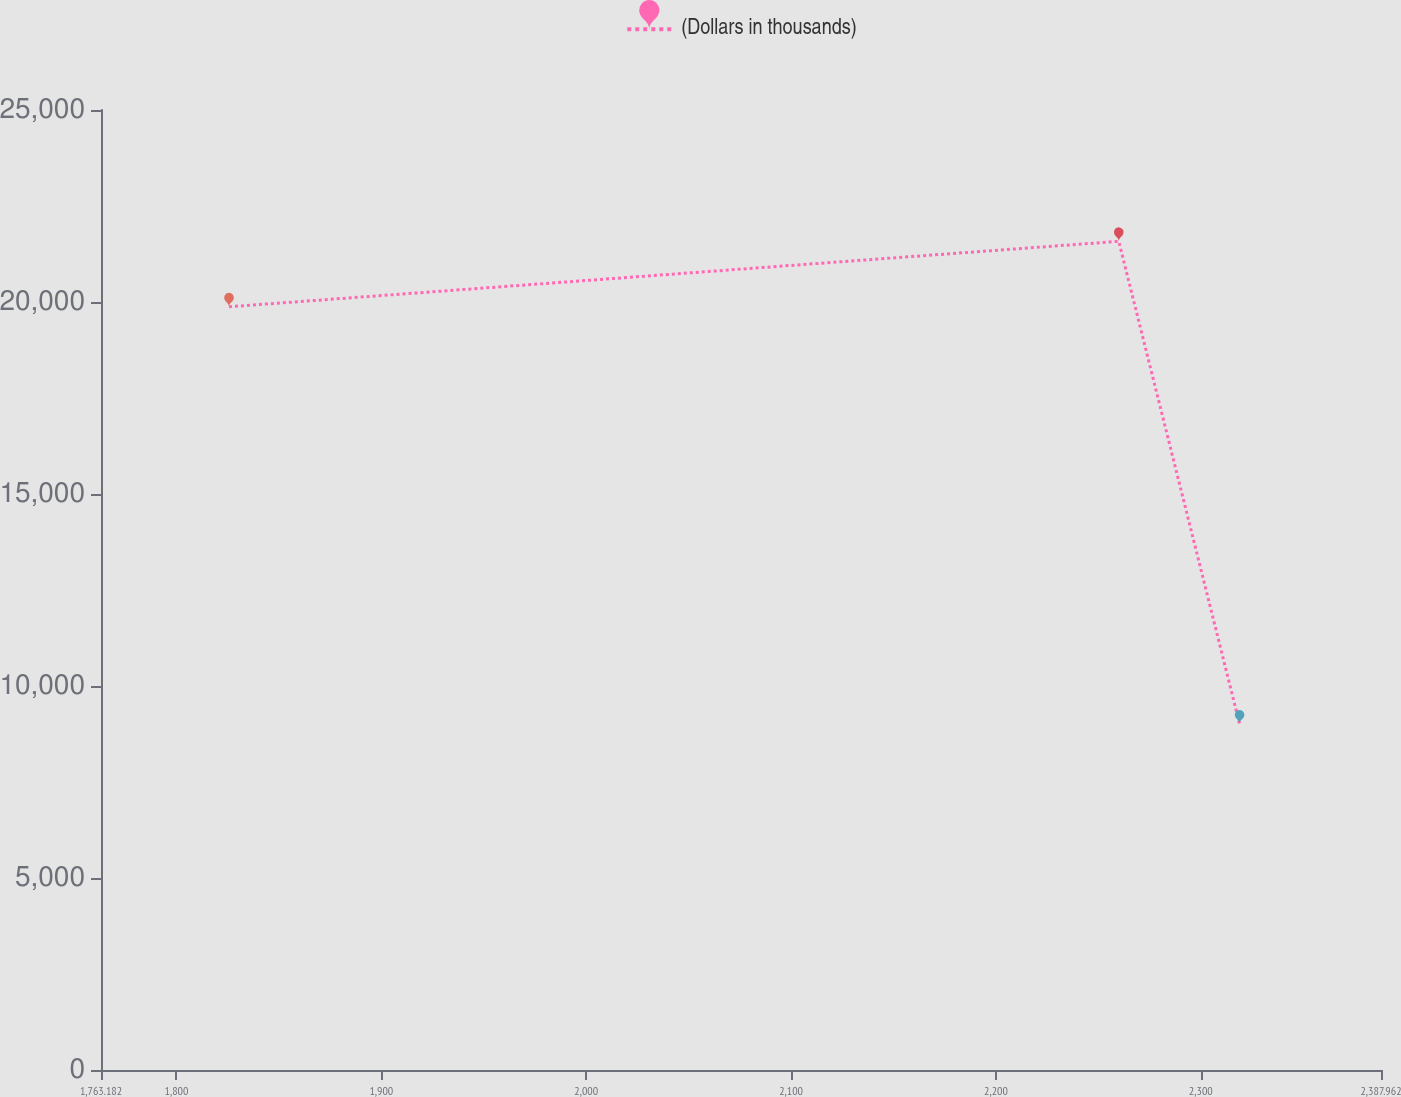Convert chart to OTSL. <chart><loc_0><loc_0><loc_500><loc_500><line_chart><ecel><fcel>(Dollars in thousands)<nl><fcel>1825.66<fcel>19876<nl><fcel>2259.97<fcel>21580.4<nl><fcel>2318.93<fcel>9012.6<nl><fcel>2391.48<fcel>11526.2<nl><fcel>2450.44<fcel>10269.4<nl></chart> 